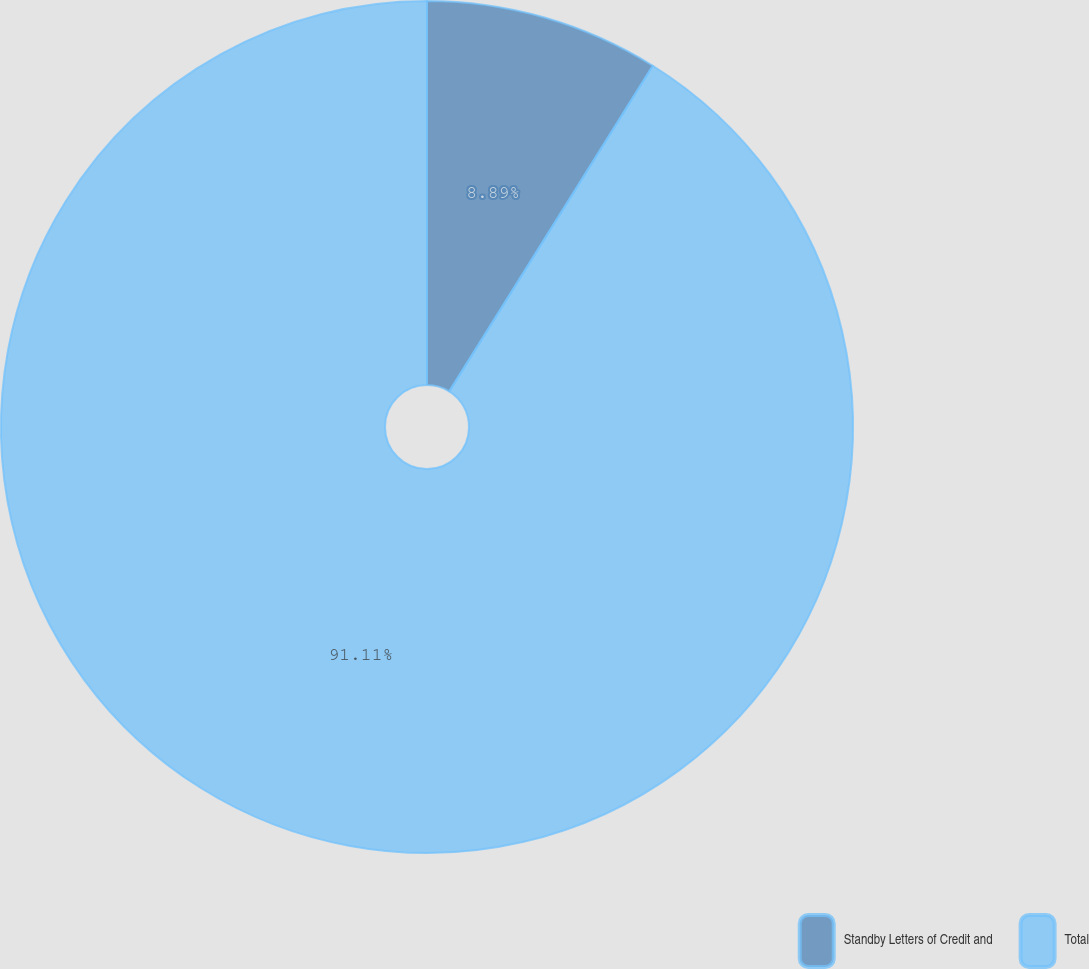Convert chart to OTSL. <chart><loc_0><loc_0><loc_500><loc_500><pie_chart><fcel>Standby Letters of Credit and<fcel>Total<nl><fcel>8.89%<fcel>91.11%<nl></chart> 